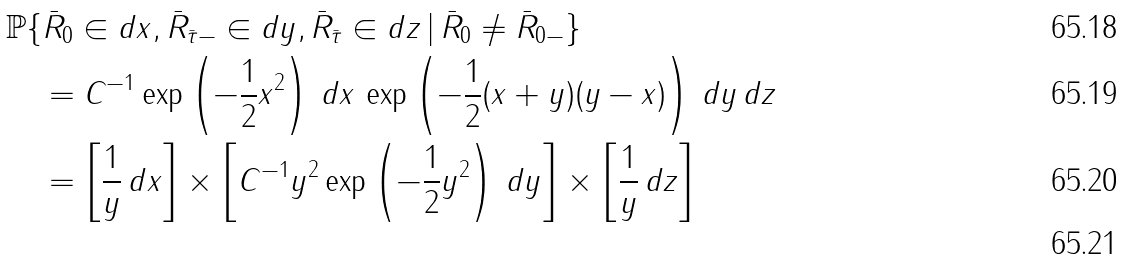<formula> <loc_0><loc_0><loc_500><loc_500>& { \mathbb { P } } \{ \bar { R } _ { 0 } \in d x , \bar { R } _ { \bar { \tau } - } \in d y , \bar { R } _ { \bar { \tau } } \in d z \, | \, \bar { R } _ { 0 } \ne \bar { R } _ { 0 - } \} \\ & \quad = C ^ { - 1 } \exp \left ( - \frac { 1 } { 2 } x ^ { 2 } \right ) \, d x \, \exp \left ( - \frac { 1 } { 2 } ( x + y ) ( y - x ) \right ) \, d y \, d z \\ & \quad = \left [ \frac { 1 } { y } \, d x \right ] \times \left [ C ^ { - 1 } y ^ { 2 } \exp \left ( - \frac { 1 } { 2 } y ^ { 2 } \right ) \, d y \right ] \times \left [ \frac { 1 } { y } \, d z \right ] \\</formula> 